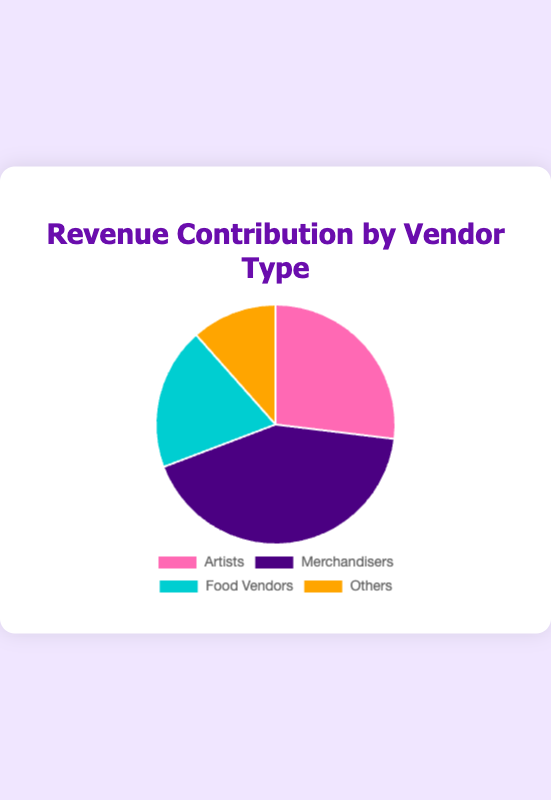Which vendor type contributes the most to the revenue? Refer to the pie chart to see which slice is the largest.
Answer: Merchandisers Which vendor type contributes the least to the revenue, and how much is it? Refer to the pie chart to identify the smallest slice.
Answer: Others, $9000 What percentage of the total revenue is generated by Food Vendors? First, sum up the total revenue: $12000 + $9000 + $18000 + $15000 + $8000 + $7000 + $5000 + $4000 = $78000. Next, sum the revenue from Food Vendors: $8000 + $7000 = $15000. Then, calculate the percentage: ($15000 / $78000) * 100 ≈ 19.2%
Answer: 19.2% How does the revenue generated by Artists compare to Merchandisers? Sum the revenue for each: Artists ($12000 + $9000 = $21000) and Merchandisers ($18000 + $15000 = $33000). Compare the sums.
Answer: Merchandisers generate more revenue What is the combined revenue contribution of 'Sakura Illustrations' and 'Manga Magic Studio'? Sum the individual revenues: $12000 + $9000 = $21000.
Answer: $21000 Which color represents the Food Vendors? Look at the legend to see which color is associated with Food Vendors.
Answer: Turquoise What is the revenue difference between 'Anime Merch Haven' and 'Otaku Treasures'? Subtract the revenue of 'Otaku Treasures' from 'Anime Merch Haven': $18000 - $15000 = $3000.
Answer: $3000 What is the total revenue generated by Artists and Others combined? Sum up the revenue for Artists and Others: ($12000 + $9000) + ($5000 + $4000) = $21000 + $9000 = $30000.
Answer: $30000 How does the revenue generated by 'Sushi Samurai' compare to 'Ramen Retreat'? Compare the individual revenues: $8000 and $7000. Sushi Samurai generates more revenue.
Answer: Sushi Samurai generates more What fraction of the total revenue is generated by 'Cosplay Accessories'? Calculate the total revenue ($78000), then find the fraction contributed by 'Cosplay Accessories': $5000 / $78000 = 5/78 ≈ 0.064.
Answer: 0.064 (or ~6.4%) 